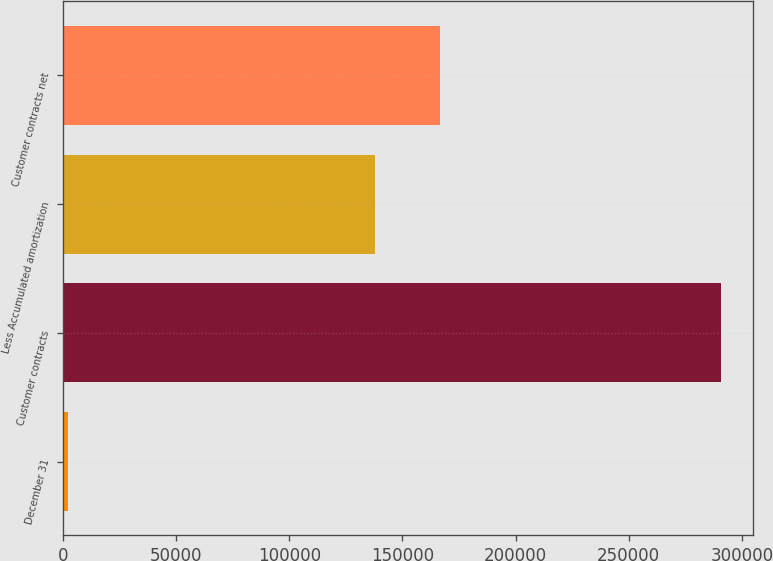Convert chart. <chart><loc_0><loc_0><loc_500><loc_500><bar_chart><fcel>December 31<fcel>Customer contracts<fcel>Less Accumulated amortization<fcel>Customer contracts net<nl><fcel>2017<fcel>290628<fcel>137759<fcel>166620<nl></chart> 